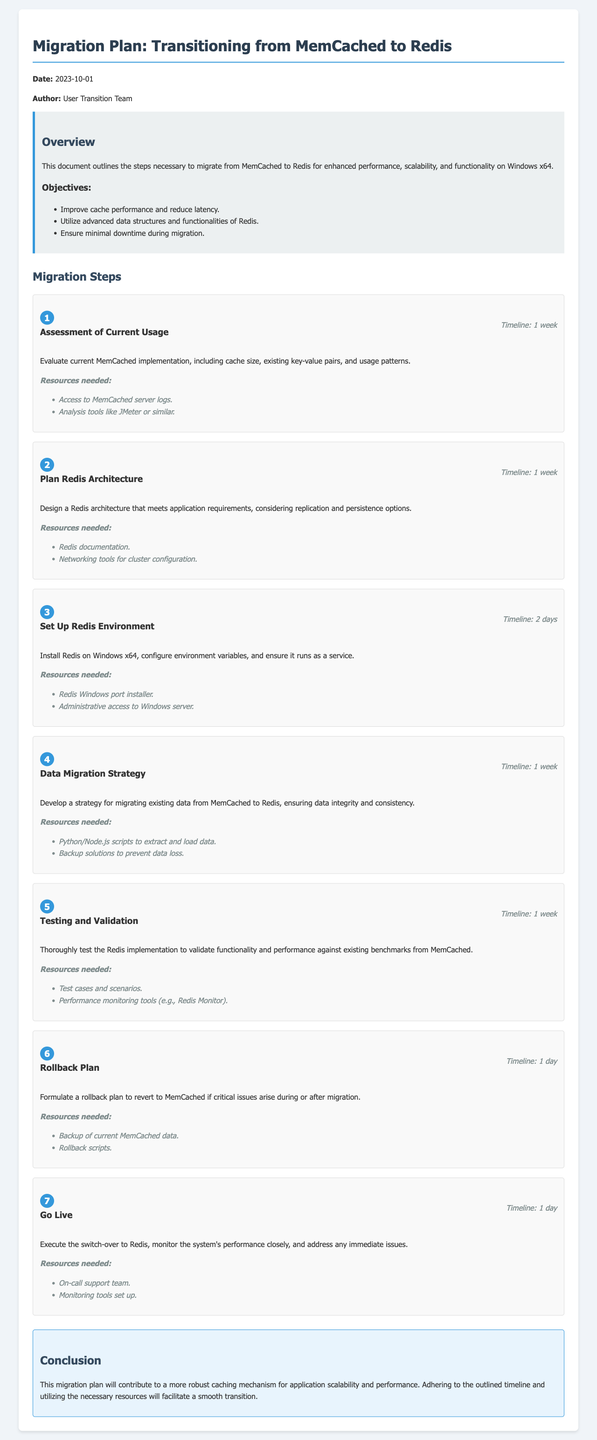What is the date of the migration plan? The date is explicitly stated at the beginning of the document.
Answer: 2023-10-01 Who is the author of the document? The author information is provided in the header section of the document.
Answer: User Transition Team What is the first step in the migration process? The first step is listed under the migration steps section and describes the initial assessment.
Answer: Assessment of Current Usage How long is the timeline for planning the Redis architecture? The timeline for planning is mentioned in the step header for that specific step.
Answer: 1 week What resources are needed for testing and validation? The required resources for this step are mentioned directly under its description.
Answer: Test cases and scenarios, Performance monitoring tools What is the final step before going live? The document outlines the steps in sequence leading to the final go-live action.
Answer: Go Live How long will the rollback plan take to execute? The timeline for the rollback plan is indicated in the document under its specific step.
Answer: 1 day What is the main objective of the migration? The objectives are listed at the beginning of the overview section of the document.
Answer: Improve cache performance and reduce latency What environment is Redis to be installed on? The document specifies the environment in context of the migration steps.
Answer: Windows x64 